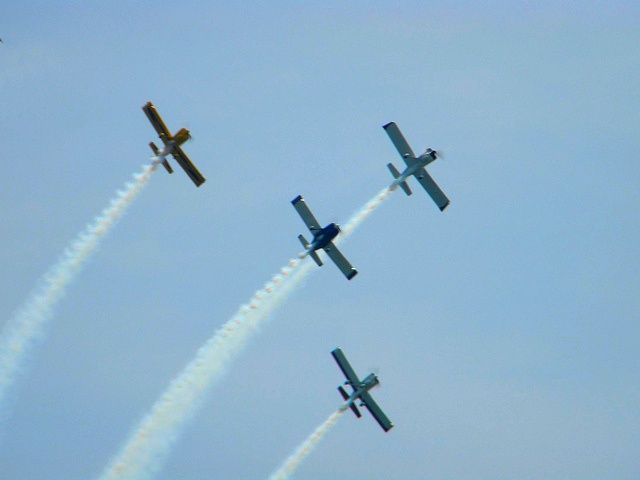Describe the objects in this image and their specific colors. I can see airplane in darkgray, blue, navy, black, and gray tones, airplane in darkgray, blue, gray, and teal tones, airplane in darkgray, black, gray, and lightblue tones, and airplane in darkgray, teal, black, and navy tones in this image. 